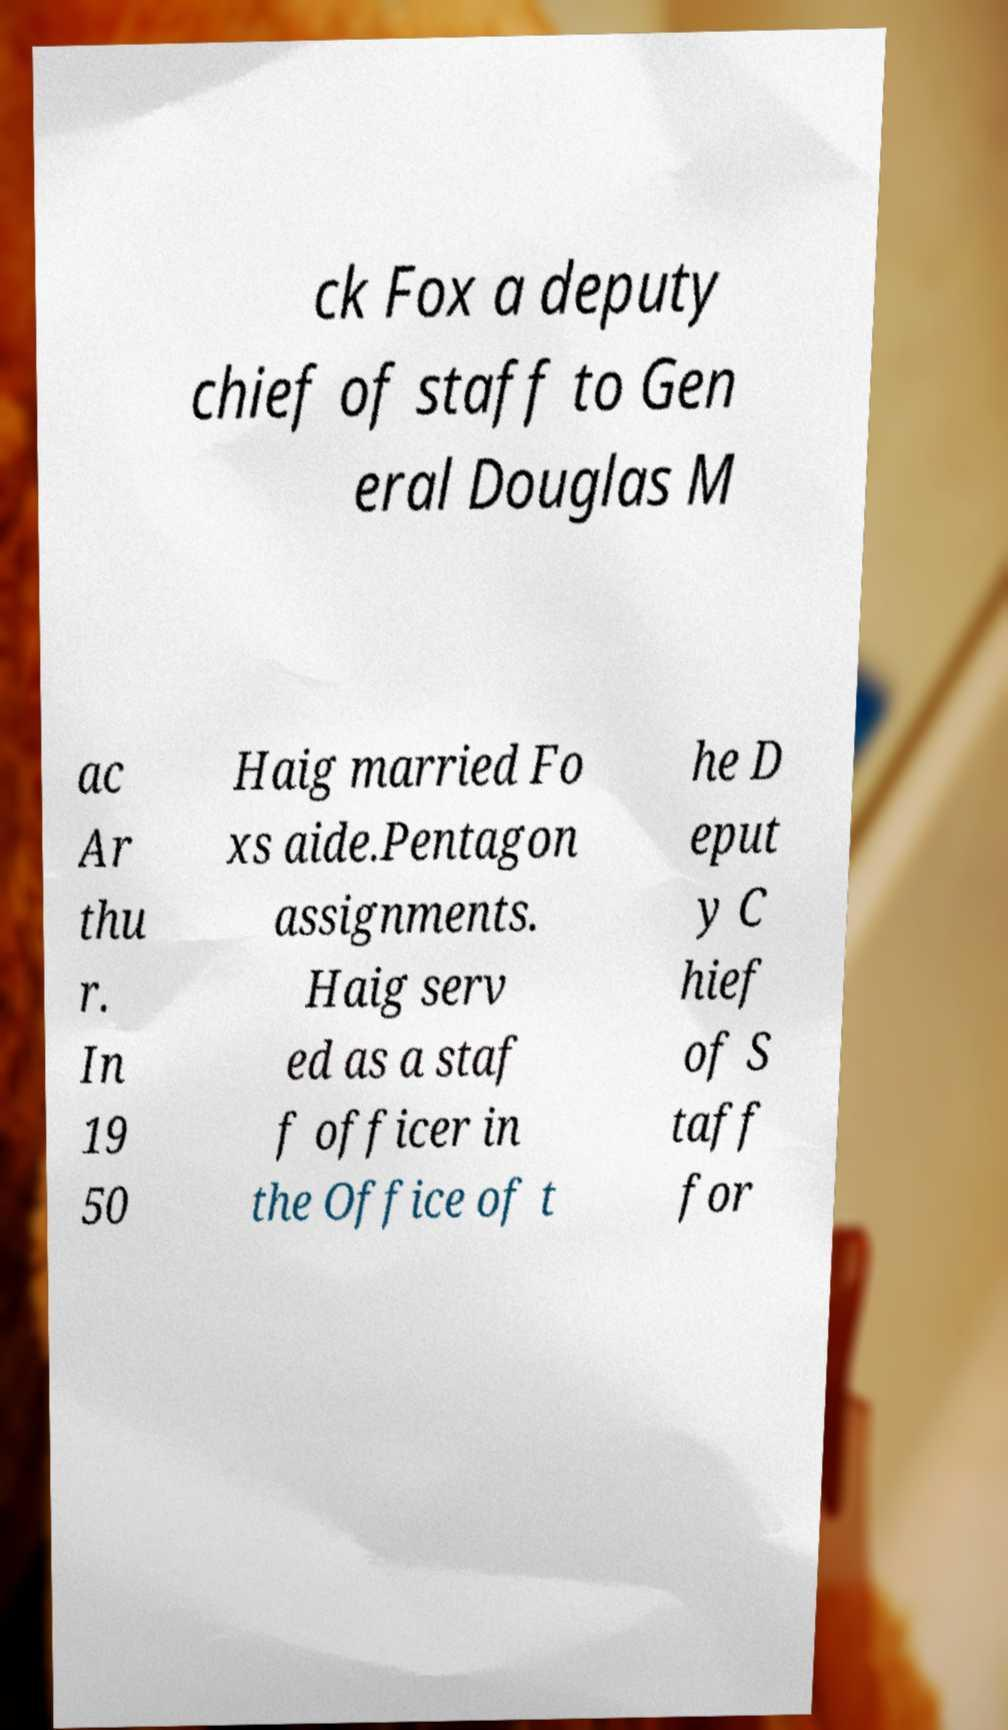For documentation purposes, I need the text within this image transcribed. Could you provide that? ck Fox a deputy chief of staff to Gen eral Douglas M ac Ar thu r. In 19 50 Haig married Fo xs aide.Pentagon assignments. Haig serv ed as a staf f officer in the Office of t he D eput y C hief of S taff for 